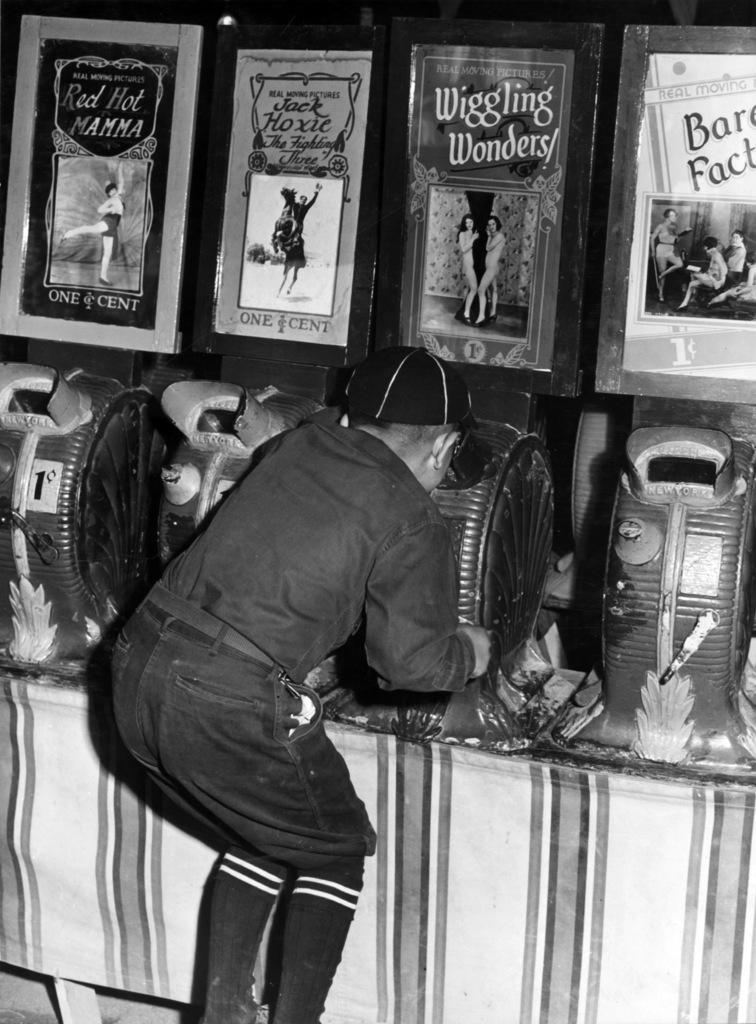In one or two sentences, can you explain what this image depicts? In this image, we can see a person. Background there is a table, few objects are placed on it. Top of the image, we can see some posters. 